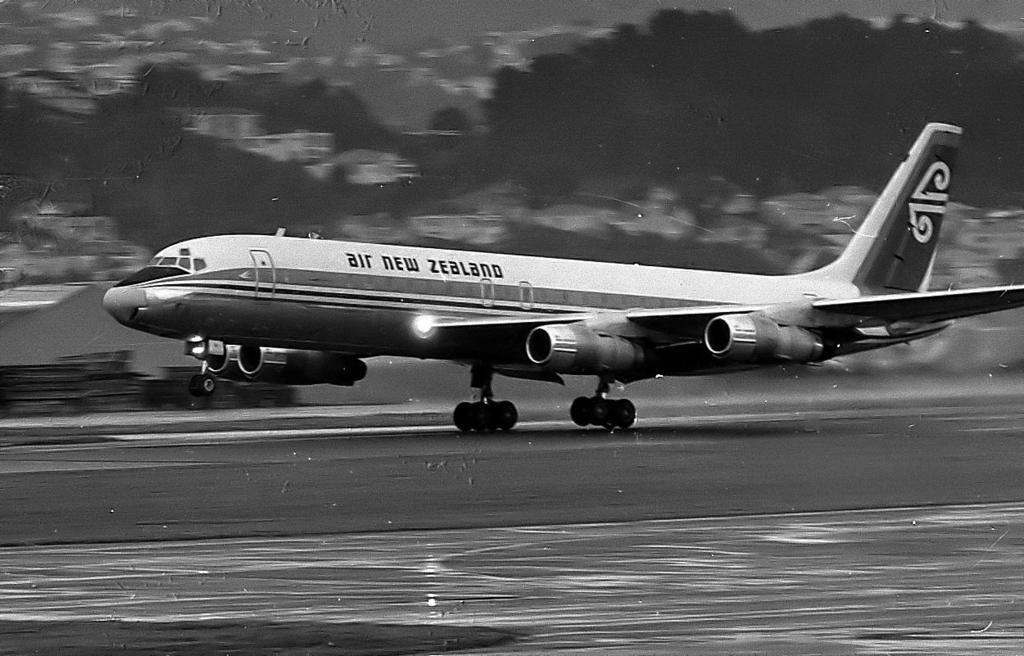Whats the name of the airport?
Your answer should be compact. New zealand. What is the of the airline shown in the photo?
Keep it short and to the point. Air new zealand. 